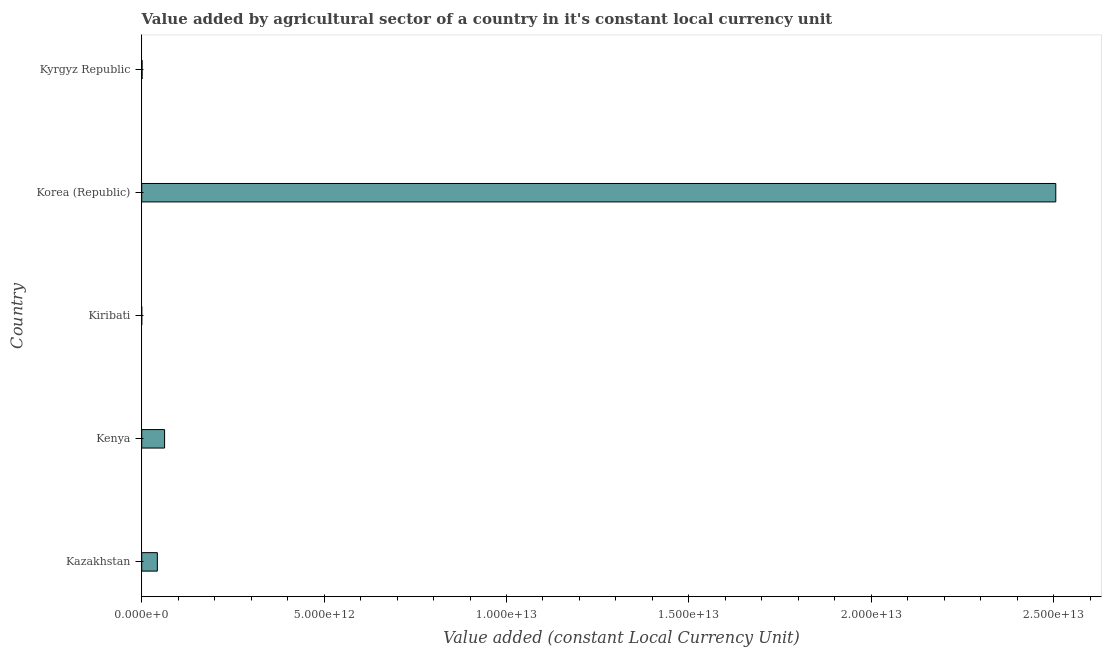What is the title of the graph?
Your answer should be very brief. Value added by agricultural sector of a country in it's constant local currency unit. What is the label or title of the X-axis?
Provide a succinct answer. Value added (constant Local Currency Unit). What is the label or title of the Y-axis?
Make the answer very short. Country. What is the value added by agriculture sector in Kyrgyz Republic?
Offer a terse response. 1.04e+1. Across all countries, what is the maximum value added by agriculture sector?
Offer a very short reply. 2.51e+13. Across all countries, what is the minimum value added by agriculture sector?
Ensure brevity in your answer.  3.18e+07. In which country was the value added by agriculture sector maximum?
Provide a succinct answer. Korea (Republic). In which country was the value added by agriculture sector minimum?
Keep it short and to the point. Kiribati. What is the sum of the value added by agriculture sector?
Provide a short and direct response. 2.61e+13. What is the difference between the value added by agriculture sector in Kazakhstan and Kiribati?
Offer a very short reply. 4.28e+11. What is the average value added by agriculture sector per country?
Offer a terse response. 5.23e+12. What is the median value added by agriculture sector?
Provide a succinct answer. 4.28e+11. Is the difference between the value added by agriculture sector in Kazakhstan and Korea (Republic) greater than the difference between any two countries?
Give a very brief answer. No. What is the difference between the highest and the second highest value added by agriculture sector?
Offer a very short reply. 2.44e+13. What is the difference between the highest and the lowest value added by agriculture sector?
Your response must be concise. 2.51e+13. In how many countries, is the value added by agriculture sector greater than the average value added by agriculture sector taken over all countries?
Your answer should be very brief. 1. What is the difference between two consecutive major ticks on the X-axis?
Keep it short and to the point. 5.00e+12. Are the values on the major ticks of X-axis written in scientific E-notation?
Provide a short and direct response. Yes. What is the Value added (constant Local Currency Unit) in Kazakhstan?
Keep it short and to the point. 4.28e+11. What is the Value added (constant Local Currency Unit) in Kenya?
Provide a succinct answer. 6.27e+11. What is the Value added (constant Local Currency Unit) in Kiribati?
Offer a terse response. 3.18e+07. What is the Value added (constant Local Currency Unit) of Korea (Republic)?
Ensure brevity in your answer.  2.51e+13. What is the Value added (constant Local Currency Unit) of Kyrgyz Republic?
Provide a succinct answer. 1.04e+1. What is the difference between the Value added (constant Local Currency Unit) in Kazakhstan and Kenya?
Make the answer very short. -1.98e+11. What is the difference between the Value added (constant Local Currency Unit) in Kazakhstan and Kiribati?
Provide a succinct answer. 4.28e+11. What is the difference between the Value added (constant Local Currency Unit) in Kazakhstan and Korea (Republic)?
Your answer should be very brief. -2.46e+13. What is the difference between the Value added (constant Local Currency Unit) in Kazakhstan and Kyrgyz Republic?
Make the answer very short. 4.18e+11. What is the difference between the Value added (constant Local Currency Unit) in Kenya and Kiribati?
Keep it short and to the point. 6.27e+11. What is the difference between the Value added (constant Local Currency Unit) in Kenya and Korea (Republic)?
Ensure brevity in your answer.  -2.44e+13. What is the difference between the Value added (constant Local Currency Unit) in Kenya and Kyrgyz Republic?
Your answer should be very brief. 6.16e+11. What is the difference between the Value added (constant Local Currency Unit) in Kiribati and Korea (Republic)?
Offer a very short reply. -2.51e+13. What is the difference between the Value added (constant Local Currency Unit) in Kiribati and Kyrgyz Republic?
Give a very brief answer. -1.04e+1. What is the difference between the Value added (constant Local Currency Unit) in Korea (Republic) and Kyrgyz Republic?
Offer a very short reply. 2.50e+13. What is the ratio of the Value added (constant Local Currency Unit) in Kazakhstan to that in Kenya?
Provide a succinct answer. 0.68. What is the ratio of the Value added (constant Local Currency Unit) in Kazakhstan to that in Kiribati?
Your answer should be compact. 1.35e+04. What is the ratio of the Value added (constant Local Currency Unit) in Kazakhstan to that in Korea (Republic)?
Your response must be concise. 0.02. What is the ratio of the Value added (constant Local Currency Unit) in Kazakhstan to that in Kyrgyz Republic?
Offer a very short reply. 41.1. What is the ratio of the Value added (constant Local Currency Unit) in Kenya to that in Kiribati?
Give a very brief answer. 1.97e+04. What is the ratio of the Value added (constant Local Currency Unit) in Kenya to that in Korea (Republic)?
Ensure brevity in your answer.  0.03. What is the ratio of the Value added (constant Local Currency Unit) in Kenya to that in Kyrgyz Republic?
Make the answer very short. 60.14. What is the ratio of the Value added (constant Local Currency Unit) in Kiribati to that in Kyrgyz Republic?
Your response must be concise. 0. What is the ratio of the Value added (constant Local Currency Unit) in Korea (Republic) to that in Kyrgyz Republic?
Offer a terse response. 2404.08. 